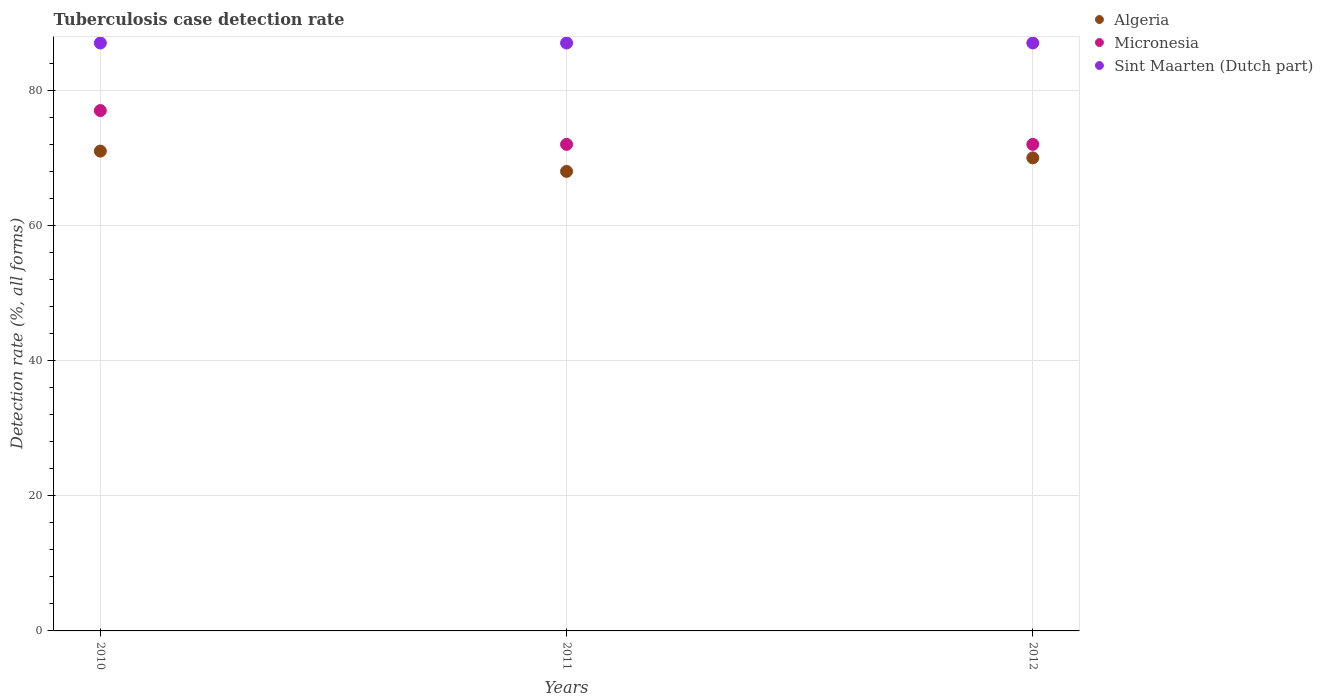How many different coloured dotlines are there?
Offer a very short reply. 3. What is the tuberculosis case detection rate in in Sint Maarten (Dutch part) in 2011?
Your response must be concise. 87. Across all years, what is the maximum tuberculosis case detection rate in in Sint Maarten (Dutch part)?
Ensure brevity in your answer.  87. Across all years, what is the minimum tuberculosis case detection rate in in Algeria?
Provide a short and direct response. 68. In which year was the tuberculosis case detection rate in in Algeria minimum?
Keep it short and to the point. 2011. What is the total tuberculosis case detection rate in in Sint Maarten (Dutch part) in the graph?
Your answer should be very brief. 261. What is the difference between the tuberculosis case detection rate in in Algeria in 2011 and that in 2012?
Give a very brief answer. -2. What is the difference between the tuberculosis case detection rate in in Algeria in 2012 and the tuberculosis case detection rate in in Sint Maarten (Dutch part) in 2010?
Provide a short and direct response. -17. What is the average tuberculosis case detection rate in in Sint Maarten (Dutch part) per year?
Ensure brevity in your answer.  87. In the year 2012, what is the difference between the tuberculosis case detection rate in in Micronesia and tuberculosis case detection rate in in Algeria?
Your response must be concise. 2. In how many years, is the tuberculosis case detection rate in in Micronesia greater than 8 %?
Your response must be concise. 3. What is the ratio of the tuberculosis case detection rate in in Algeria in 2010 to that in 2011?
Keep it short and to the point. 1.04. What is the difference between the highest and the second highest tuberculosis case detection rate in in Algeria?
Give a very brief answer. 1. What is the difference between the highest and the lowest tuberculosis case detection rate in in Algeria?
Your answer should be very brief. 3. In how many years, is the tuberculosis case detection rate in in Algeria greater than the average tuberculosis case detection rate in in Algeria taken over all years?
Your answer should be very brief. 2. Does the tuberculosis case detection rate in in Micronesia monotonically increase over the years?
Your answer should be very brief. No. Is the tuberculosis case detection rate in in Algeria strictly less than the tuberculosis case detection rate in in Sint Maarten (Dutch part) over the years?
Your response must be concise. Yes. How many years are there in the graph?
Offer a very short reply. 3. What is the difference between two consecutive major ticks on the Y-axis?
Offer a terse response. 20. Are the values on the major ticks of Y-axis written in scientific E-notation?
Offer a terse response. No. Does the graph contain grids?
Provide a short and direct response. Yes. Where does the legend appear in the graph?
Give a very brief answer. Top right. How are the legend labels stacked?
Keep it short and to the point. Vertical. What is the title of the graph?
Offer a very short reply. Tuberculosis case detection rate. Does "Mongolia" appear as one of the legend labels in the graph?
Provide a short and direct response. No. What is the label or title of the X-axis?
Provide a short and direct response. Years. What is the label or title of the Y-axis?
Provide a short and direct response. Detection rate (%, all forms). What is the Detection rate (%, all forms) in Sint Maarten (Dutch part) in 2011?
Ensure brevity in your answer.  87. What is the Detection rate (%, all forms) of Algeria in 2012?
Provide a succinct answer. 70. What is the Detection rate (%, all forms) of Micronesia in 2012?
Your answer should be compact. 72. Across all years, what is the minimum Detection rate (%, all forms) in Sint Maarten (Dutch part)?
Provide a short and direct response. 87. What is the total Detection rate (%, all forms) of Algeria in the graph?
Your answer should be very brief. 209. What is the total Detection rate (%, all forms) in Micronesia in the graph?
Your answer should be compact. 221. What is the total Detection rate (%, all forms) in Sint Maarten (Dutch part) in the graph?
Offer a very short reply. 261. What is the difference between the Detection rate (%, all forms) of Algeria in 2010 and that in 2011?
Offer a terse response. 3. What is the difference between the Detection rate (%, all forms) in Micronesia in 2010 and that in 2011?
Provide a short and direct response. 5. What is the difference between the Detection rate (%, all forms) of Sint Maarten (Dutch part) in 2011 and that in 2012?
Your answer should be very brief. 0. What is the difference between the Detection rate (%, all forms) of Algeria in 2010 and the Detection rate (%, all forms) of Micronesia in 2011?
Give a very brief answer. -1. What is the difference between the Detection rate (%, all forms) in Algeria in 2010 and the Detection rate (%, all forms) in Sint Maarten (Dutch part) in 2011?
Offer a terse response. -16. What is the difference between the Detection rate (%, all forms) in Micronesia in 2010 and the Detection rate (%, all forms) in Sint Maarten (Dutch part) in 2011?
Your answer should be very brief. -10. What is the difference between the Detection rate (%, all forms) of Algeria in 2010 and the Detection rate (%, all forms) of Sint Maarten (Dutch part) in 2012?
Provide a succinct answer. -16. What is the difference between the Detection rate (%, all forms) in Micronesia in 2010 and the Detection rate (%, all forms) in Sint Maarten (Dutch part) in 2012?
Your response must be concise. -10. What is the difference between the Detection rate (%, all forms) of Algeria in 2011 and the Detection rate (%, all forms) of Micronesia in 2012?
Keep it short and to the point. -4. What is the difference between the Detection rate (%, all forms) in Algeria in 2011 and the Detection rate (%, all forms) in Sint Maarten (Dutch part) in 2012?
Provide a succinct answer. -19. What is the difference between the Detection rate (%, all forms) of Micronesia in 2011 and the Detection rate (%, all forms) of Sint Maarten (Dutch part) in 2012?
Ensure brevity in your answer.  -15. What is the average Detection rate (%, all forms) in Algeria per year?
Provide a succinct answer. 69.67. What is the average Detection rate (%, all forms) in Micronesia per year?
Provide a succinct answer. 73.67. What is the average Detection rate (%, all forms) in Sint Maarten (Dutch part) per year?
Your answer should be compact. 87. In the year 2010, what is the difference between the Detection rate (%, all forms) in Algeria and Detection rate (%, all forms) in Micronesia?
Make the answer very short. -6. In the year 2010, what is the difference between the Detection rate (%, all forms) in Micronesia and Detection rate (%, all forms) in Sint Maarten (Dutch part)?
Your response must be concise. -10. In the year 2012, what is the difference between the Detection rate (%, all forms) of Algeria and Detection rate (%, all forms) of Sint Maarten (Dutch part)?
Provide a succinct answer. -17. In the year 2012, what is the difference between the Detection rate (%, all forms) in Micronesia and Detection rate (%, all forms) in Sint Maarten (Dutch part)?
Provide a succinct answer. -15. What is the ratio of the Detection rate (%, all forms) of Algeria in 2010 to that in 2011?
Keep it short and to the point. 1.04. What is the ratio of the Detection rate (%, all forms) in Micronesia in 2010 to that in 2011?
Your response must be concise. 1.07. What is the ratio of the Detection rate (%, all forms) in Sint Maarten (Dutch part) in 2010 to that in 2011?
Offer a very short reply. 1. What is the ratio of the Detection rate (%, all forms) in Algeria in 2010 to that in 2012?
Your answer should be very brief. 1.01. What is the ratio of the Detection rate (%, all forms) of Micronesia in 2010 to that in 2012?
Your answer should be very brief. 1.07. What is the ratio of the Detection rate (%, all forms) of Sint Maarten (Dutch part) in 2010 to that in 2012?
Keep it short and to the point. 1. What is the ratio of the Detection rate (%, all forms) of Algeria in 2011 to that in 2012?
Your response must be concise. 0.97. What is the ratio of the Detection rate (%, all forms) in Micronesia in 2011 to that in 2012?
Make the answer very short. 1. What is the ratio of the Detection rate (%, all forms) in Sint Maarten (Dutch part) in 2011 to that in 2012?
Offer a terse response. 1. What is the difference between the highest and the second highest Detection rate (%, all forms) in Algeria?
Provide a short and direct response. 1. What is the difference between the highest and the second highest Detection rate (%, all forms) in Micronesia?
Offer a very short reply. 5. What is the difference between the highest and the second highest Detection rate (%, all forms) in Sint Maarten (Dutch part)?
Ensure brevity in your answer.  0. What is the difference between the highest and the lowest Detection rate (%, all forms) in Algeria?
Provide a succinct answer. 3. 